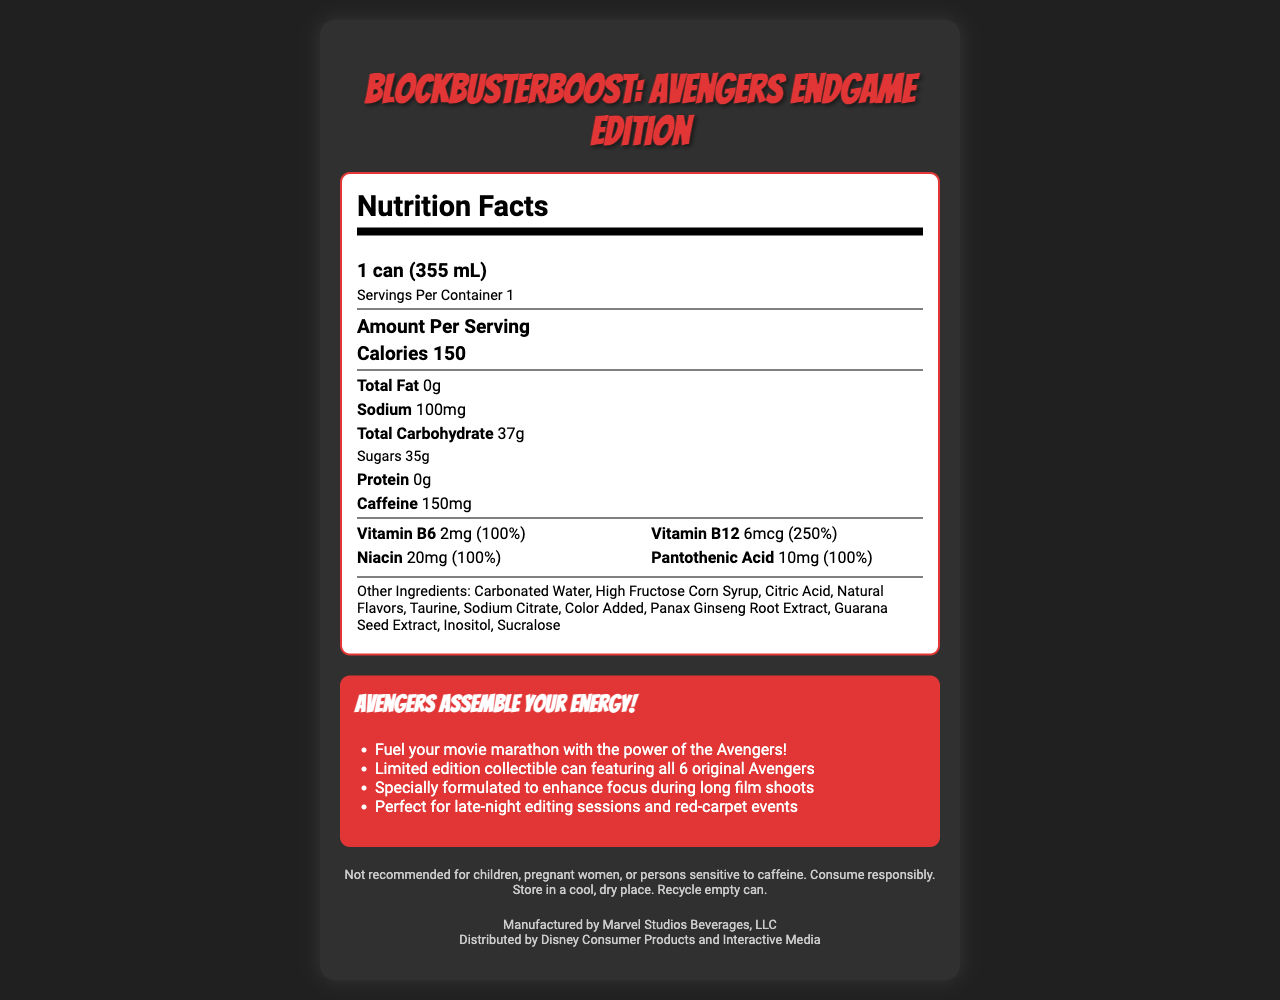What is the serving size of BlockbusterBoost: Avengers Endgame Edition? The serving size is mentioned at the top of the nutrition label under the "Nutrition Facts" section.
Answer: 1 can (355 mL) How many calories are there per serving? The calories per serving are listed under the "Amount Per Serving" section.
Answer: 150 How much caffeine does one can contain? The amount of caffeine per serving is clearly highlighted in the nutrition label.
Answer: 150mg What percentage of the daily value of Vitamin B12 is in this drink? The daily value percentage for Vitamin B12 is listed as 250% in the vitamins and minerals section.
Answer: 250% List two of the main marketing claims associated with this product. These claims are found in the marketing section of the document.
Answer: (1) Fuel your movie marathon with the power of the Avengers! (2) Limited edition collectible can featuring all 6 original Avengers Which of the following ingredients is NOT listed in the other ingredients section? A. High Fructose Corn Syrup B. Ascorbic Acid C. Panax Ginseng Root Extract D. Sucralose Ascorbic Acid is not listed among the other ingredients.
Answer: B. Ascorbic Acid How much sodium is in one serving of this energy drink? A. 50mg B. 100mg C. 150mg D. 200mg The amount of sodium per serving is listed as 100mg in the nutrition label.
Answer: B. 100mg True or False: The drink is recommended for children and pregnant women. The legal disclaimer specifically states that it is not recommended for children, pregnant women, or persons sensitive to caffeine.
Answer: False Summarize the key features of BlockbusterBoost: Avengers Endgame Edition. The summary captures the overall details and features emphasized in the document, including nutritional content, ingredients, and marketing claims.
Answer: BlockbusterBoost: Avengers Endgame Edition is a limited-edition energy drink containing 150 calories and 150mg of caffeine per 355 mL can. It is enriched with several vitamins (Vitamin B6, B12, Niacin, and Pantothenic Acid) and includes other ingredients such as high fructose corn syrup and natural flavors. The product also markets itself as designed to enhance focus and energy for movie marathons and late-night tasks. It comes in a collectible can and contains a disclaimer that it is not suitable for children or pregnant women. What is the amount of Pantothenic Acid in the drink? The amount of Pantothenic Acid is listed as 10mg in the vitamins and minerals section.
Answer: 10mg Who is the manufacturer of this energy drink? The manufacturer information is mentioned at the bottom of the document under the legal disclaimer section.
Answer: Marvel Studios Beverages, LLC Can you determine the price of BlockbusterBoost: Avengers Endgame Edition from the document? The document does not provide any information regarding the price of the energy drink.
Answer: Cannot be determined 